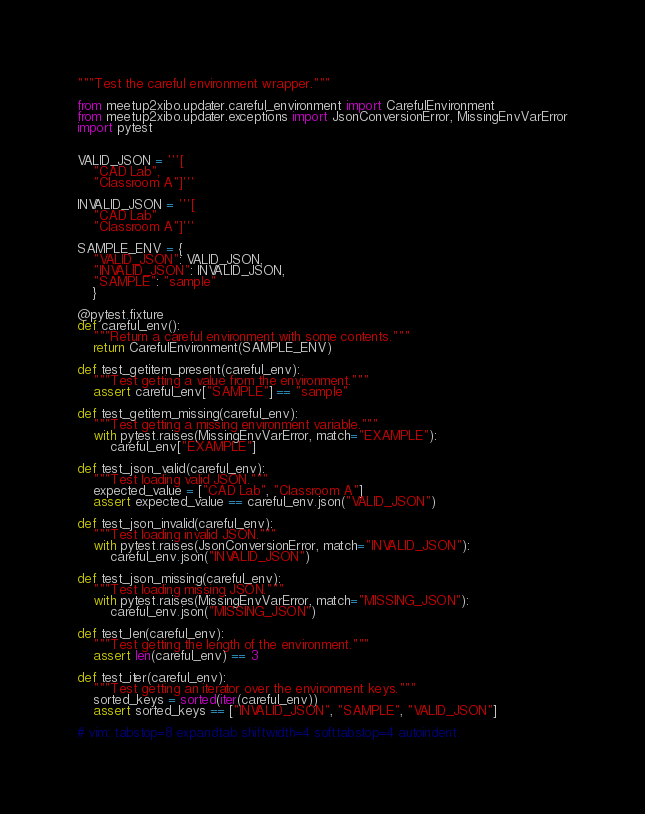Convert code to text. <code><loc_0><loc_0><loc_500><loc_500><_Python_>"""Test the careful environment wrapper."""

from meetup2xibo.updater.careful_environment import CarefulEnvironment
from meetup2xibo.updater.exceptions import JsonConversionError, MissingEnvVarError
import pytest


VALID_JSON = '''[
	"CAD Lab",
	"Classroom A"]'''

INVALID_JSON = '''[
	"CAD Lab"
	"Classroom A"]'''

SAMPLE_ENV = {
    "VALID_JSON": VALID_JSON,
    "INVALID_JSON": INVALID_JSON,
    "SAMPLE": "sample"
    }

@pytest.fixture
def careful_env():
    """Return a careful environment with some contents."""
    return CarefulEnvironment(SAMPLE_ENV)

def test_getitem_present(careful_env):
    """Test getting a value from the environment."""
    assert careful_env["SAMPLE"] == "sample"

def test_getitem_missing(careful_env):
    """Test getting a missing environment variable."""
    with pytest.raises(MissingEnvVarError, match="EXAMPLE"):
        careful_env["EXAMPLE"]

def test_json_valid(careful_env):
    """Test loading valid JSON."""
    expected_value = ["CAD Lab", "Classroom A"]
    assert expected_value == careful_env.json("VALID_JSON")

def test_json_invalid(careful_env):
    """Test loading invalid JSON."""
    with pytest.raises(JsonConversionError, match="INVALID_JSON"):
        careful_env.json("INVALID_JSON")

def test_json_missing(careful_env):
    """Test loading missing JSON."""
    with pytest.raises(MissingEnvVarError, match="MISSING_JSON"):
        careful_env.json("MISSING_JSON")

def test_len(careful_env):
    """Test getting the length of the environment."""
    assert len(careful_env) == 3

def test_iter(careful_env):
    """Test getting an iterator over the environment keys."""
    sorted_keys = sorted(iter(careful_env))
    assert sorted_keys == ["INVALID_JSON", "SAMPLE", "VALID_JSON"]

# vim: tabstop=8 expandtab shiftwidth=4 softtabstop=4 autoindent
</code> 